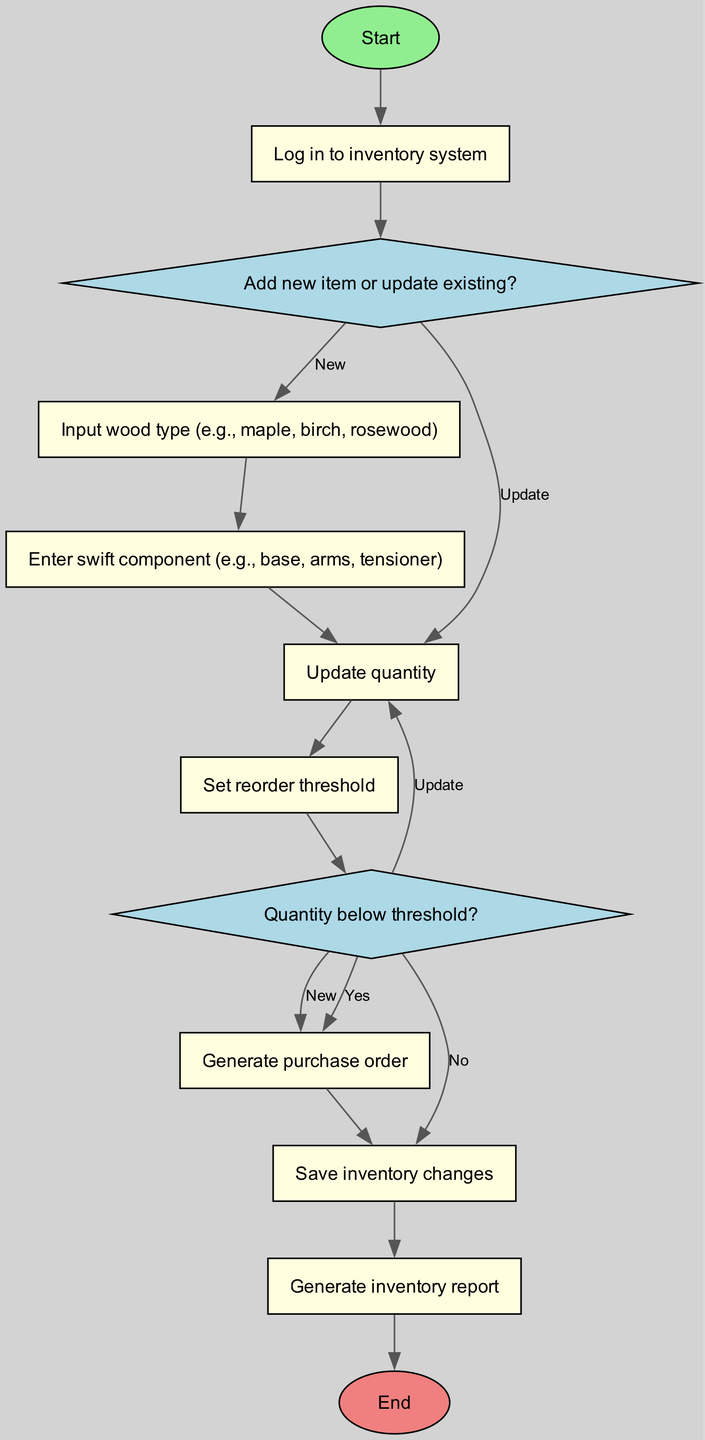What is the first step in the inventory management system? The first step is "Log in to inventory system," indicated as the starting node in the diagram.
Answer: Log in to inventory system How many decision nodes are in the diagram? There are two decision nodes, as indicated by the diamond shapes in the flowchart, specifically "Add new item or update existing?" and "Quantity below threshold?"
Answer: 2 What happens if the quantity is below the threshold? If the quantity is below the threshold, the flowchart leads to the process "Generate purchase order," as indicated by the corresponding edge from the decision node.
Answer: Generate purchase order What type of component can be entered in the inventory system? The available component type to enter is "swift component (e.g., base, arms, tensioner)," shown as a process step in the diagram.
Answer: swift component (e.g., base, arms, tensioner) What is the last step in the inventory management flow? The last step in the flow is "Generate inventory report," which is connected to the ending node of the diagram.
Answer: Generate inventory report What action is taken if a new item is added? If a new item is added, the flow directs to the process "Input wood type (e.g., maple, birch, rosewood)," making it clear that the addition of a new item corresponds with this process.
Answer: Input wood type (e.g., maple, birch, rosewood) Which process follows the decision node asking about updating an existing item? The process that follows this decision node is "Update quantity" when the selection is to update. This is clearly indicated by the flow branching from the decision.
Answer: Update quantity What does the flowchart indicate should be done after saving inventory changes? The flowchart indicates that "Generate inventory report" should be done after saving the changes, as shown in the sequence of processes.
Answer: Generate inventory report 